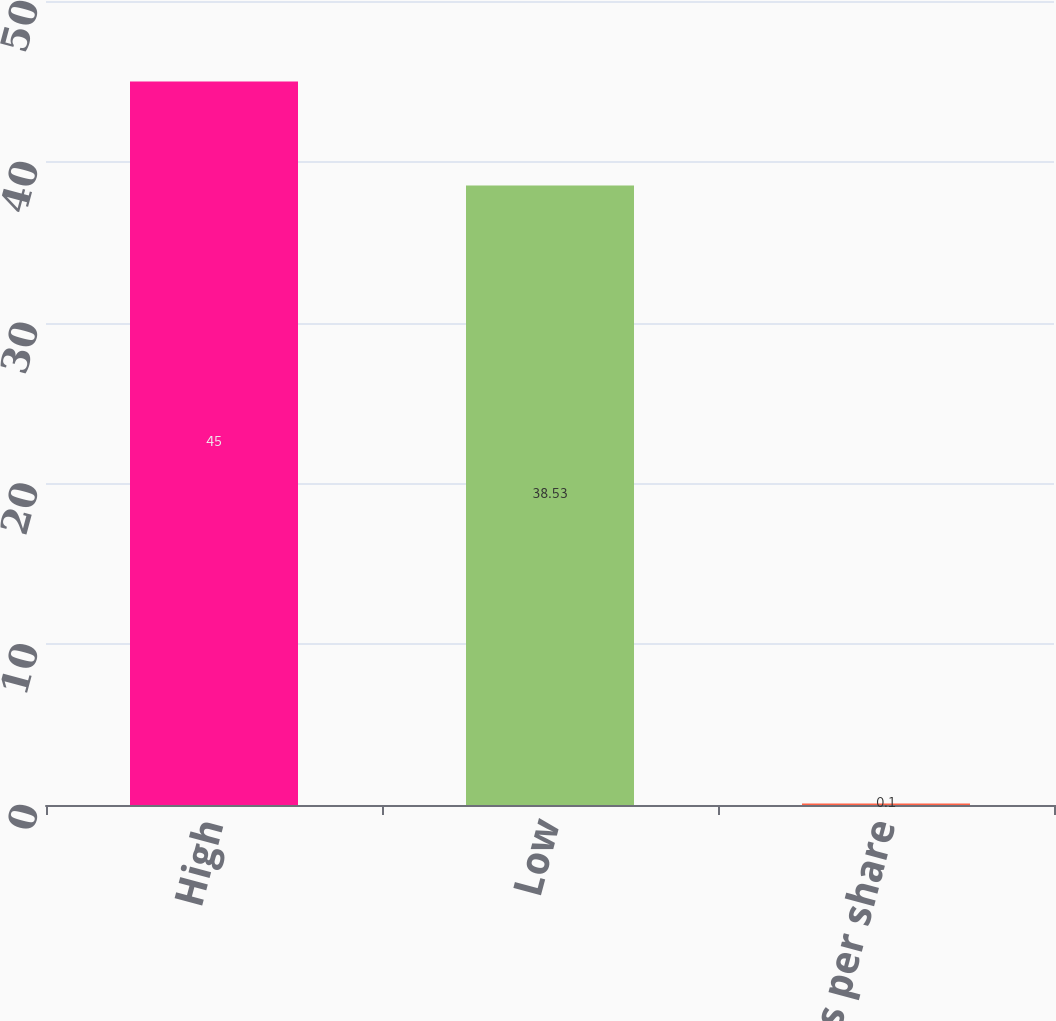Convert chart to OTSL. <chart><loc_0><loc_0><loc_500><loc_500><bar_chart><fcel>High<fcel>Low<fcel>Dividends per share<nl><fcel>45<fcel>38.53<fcel>0.1<nl></chart> 